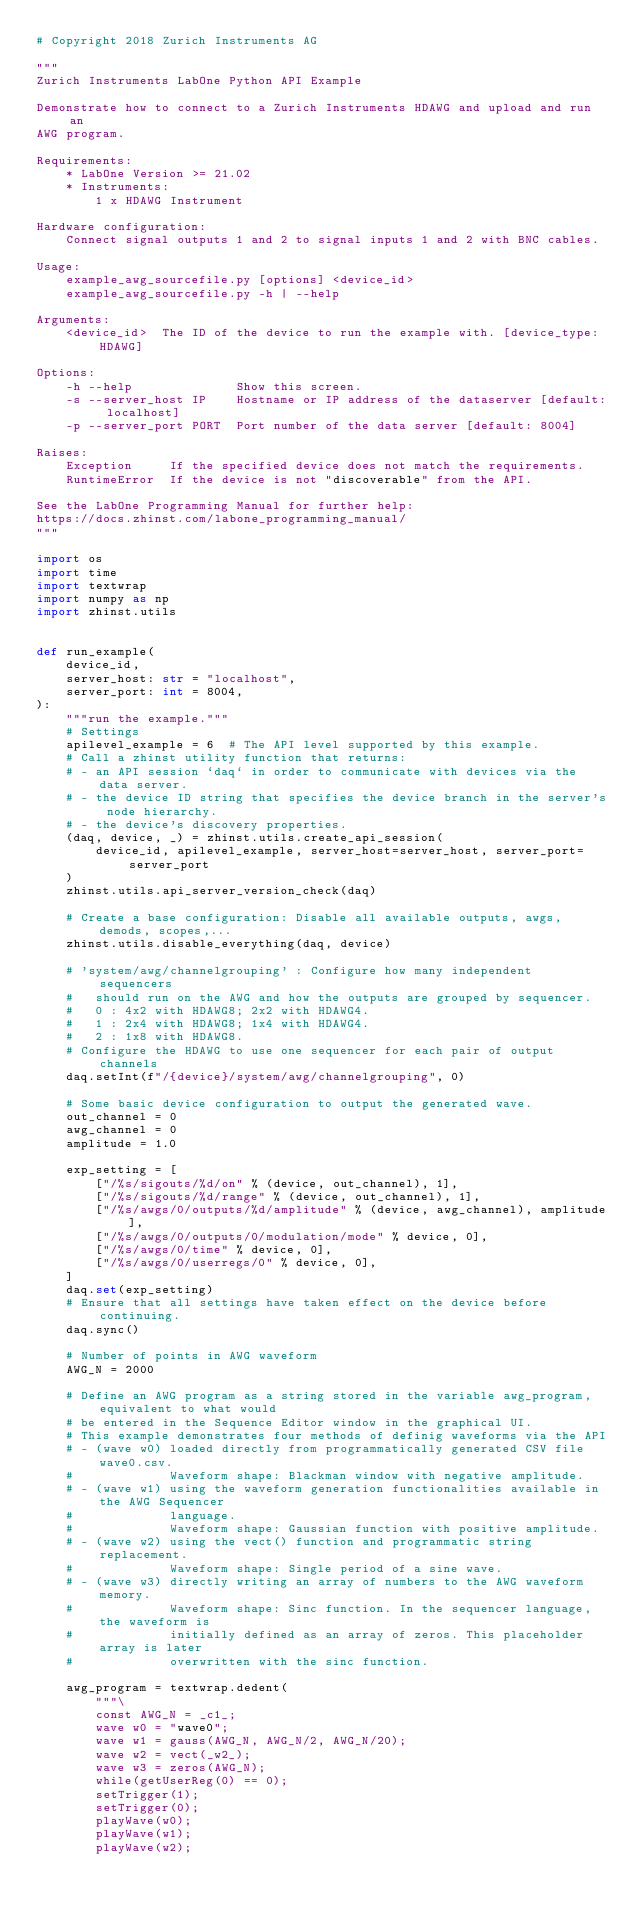Convert code to text. <code><loc_0><loc_0><loc_500><loc_500><_Python_># Copyright 2018 Zurich Instruments AG

"""
Zurich Instruments LabOne Python API Example

Demonstrate how to connect to a Zurich Instruments HDAWG and upload and run an
AWG program.

Requirements:
    * LabOne Version >= 21.02
    * Instruments:
        1 x HDAWG Instrument

Hardware configuration:
    Connect signal outputs 1 and 2 to signal inputs 1 and 2 with BNC cables.

Usage:
    example_awg_sourcefile.py [options] <device_id>
    example_awg_sourcefile.py -h | --help

Arguments:
    <device_id>  The ID of the device to run the example with. [device_type: HDAWG]

Options:
    -h --help              Show this screen.
    -s --server_host IP    Hostname or IP address of the dataserver [default: localhost]
    -p --server_port PORT  Port number of the data server [default: 8004]

Raises:
    Exception     If the specified device does not match the requirements.
    RuntimeError  If the device is not "discoverable" from the API.

See the LabOne Programming Manual for further help:
https://docs.zhinst.com/labone_programming_manual/
"""

import os
import time
import textwrap
import numpy as np
import zhinst.utils


def run_example(
    device_id,
    server_host: str = "localhost",
    server_port: int = 8004,
):
    """run the example."""
    # Settings
    apilevel_example = 6  # The API level supported by this example.
    # Call a zhinst utility function that returns:
    # - an API session `daq` in order to communicate with devices via the data server.
    # - the device ID string that specifies the device branch in the server's node hierarchy.
    # - the device's discovery properties.
    (daq, device, _) = zhinst.utils.create_api_session(
        device_id, apilevel_example, server_host=server_host, server_port=server_port
    )
    zhinst.utils.api_server_version_check(daq)

    # Create a base configuration: Disable all available outputs, awgs, demods, scopes,...
    zhinst.utils.disable_everything(daq, device)

    # 'system/awg/channelgrouping' : Configure how many independent sequencers
    #   should run on the AWG and how the outputs are grouped by sequencer.
    #   0 : 4x2 with HDAWG8; 2x2 with HDAWG4.
    #   1 : 2x4 with HDAWG8; 1x4 with HDAWG4.
    #   2 : 1x8 with HDAWG8.
    # Configure the HDAWG to use one sequencer for each pair of output channels
    daq.setInt(f"/{device}/system/awg/channelgrouping", 0)

    # Some basic device configuration to output the generated wave.
    out_channel = 0
    awg_channel = 0
    amplitude = 1.0

    exp_setting = [
        ["/%s/sigouts/%d/on" % (device, out_channel), 1],
        ["/%s/sigouts/%d/range" % (device, out_channel), 1],
        ["/%s/awgs/0/outputs/%d/amplitude" % (device, awg_channel), amplitude],
        ["/%s/awgs/0/outputs/0/modulation/mode" % device, 0],
        ["/%s/awgs/0/time" % device, 0],
        ["/%s/awgs/0/userregs/0" % device, 0],
    ]
    daq.set(exp_setting)
    # Ensure that all settings have taken effect on the device before continuing.
    daq.sync()

    # Number of points in AWG waveform
    AWG_N = 2000

    # Define an AWG program as a string stored in the variable awg_program, equivalent to what would
    # be entered in the Sequence Editor window in the graphical UI.
    # This example demonstrates four methods of definig waveforms via the API
    # - (wave w0) loaded directly from programmatically generated CSV file wave0.csv.
    #             Waveform shape: Blackman window with negative amplitude.
    # - (wave w1) using the waveform generation functionalities available in the AWG Sequencer
    #             language.
    #             Waveform shape: Gaussian function with positive amplitude.
    # - (wave w2) using the vect() function and programmatic string replacement.
    #             Waveform shape: Single period of a sine wave.
    # - (wave w3) directly writing an array of numbers to the AWG waveform memory.
    #             Waveform shape: Sinc function. In the sequencer language, the waveform is
    #             initially defined as an array of zeros. This placeholder array is later
    #             overwritten with the sinc function.

    awg_program = textwrap.dedent(
        """\
        const AWG_N = _c1_;
        wave w0 = "wave0";
        wave w1 = gauss(AWG_N, AWG_N/2, AWG_N/20);
        wave w2 = vect(_w2_);
        wave w3 = zeros(AWG_N);
        while(getUserReg(0) == 0);
        setTrigger(1);
        setTrigger(0);
        playWave(w0);
        playWave(w1);
        playWave(w2);</code> 